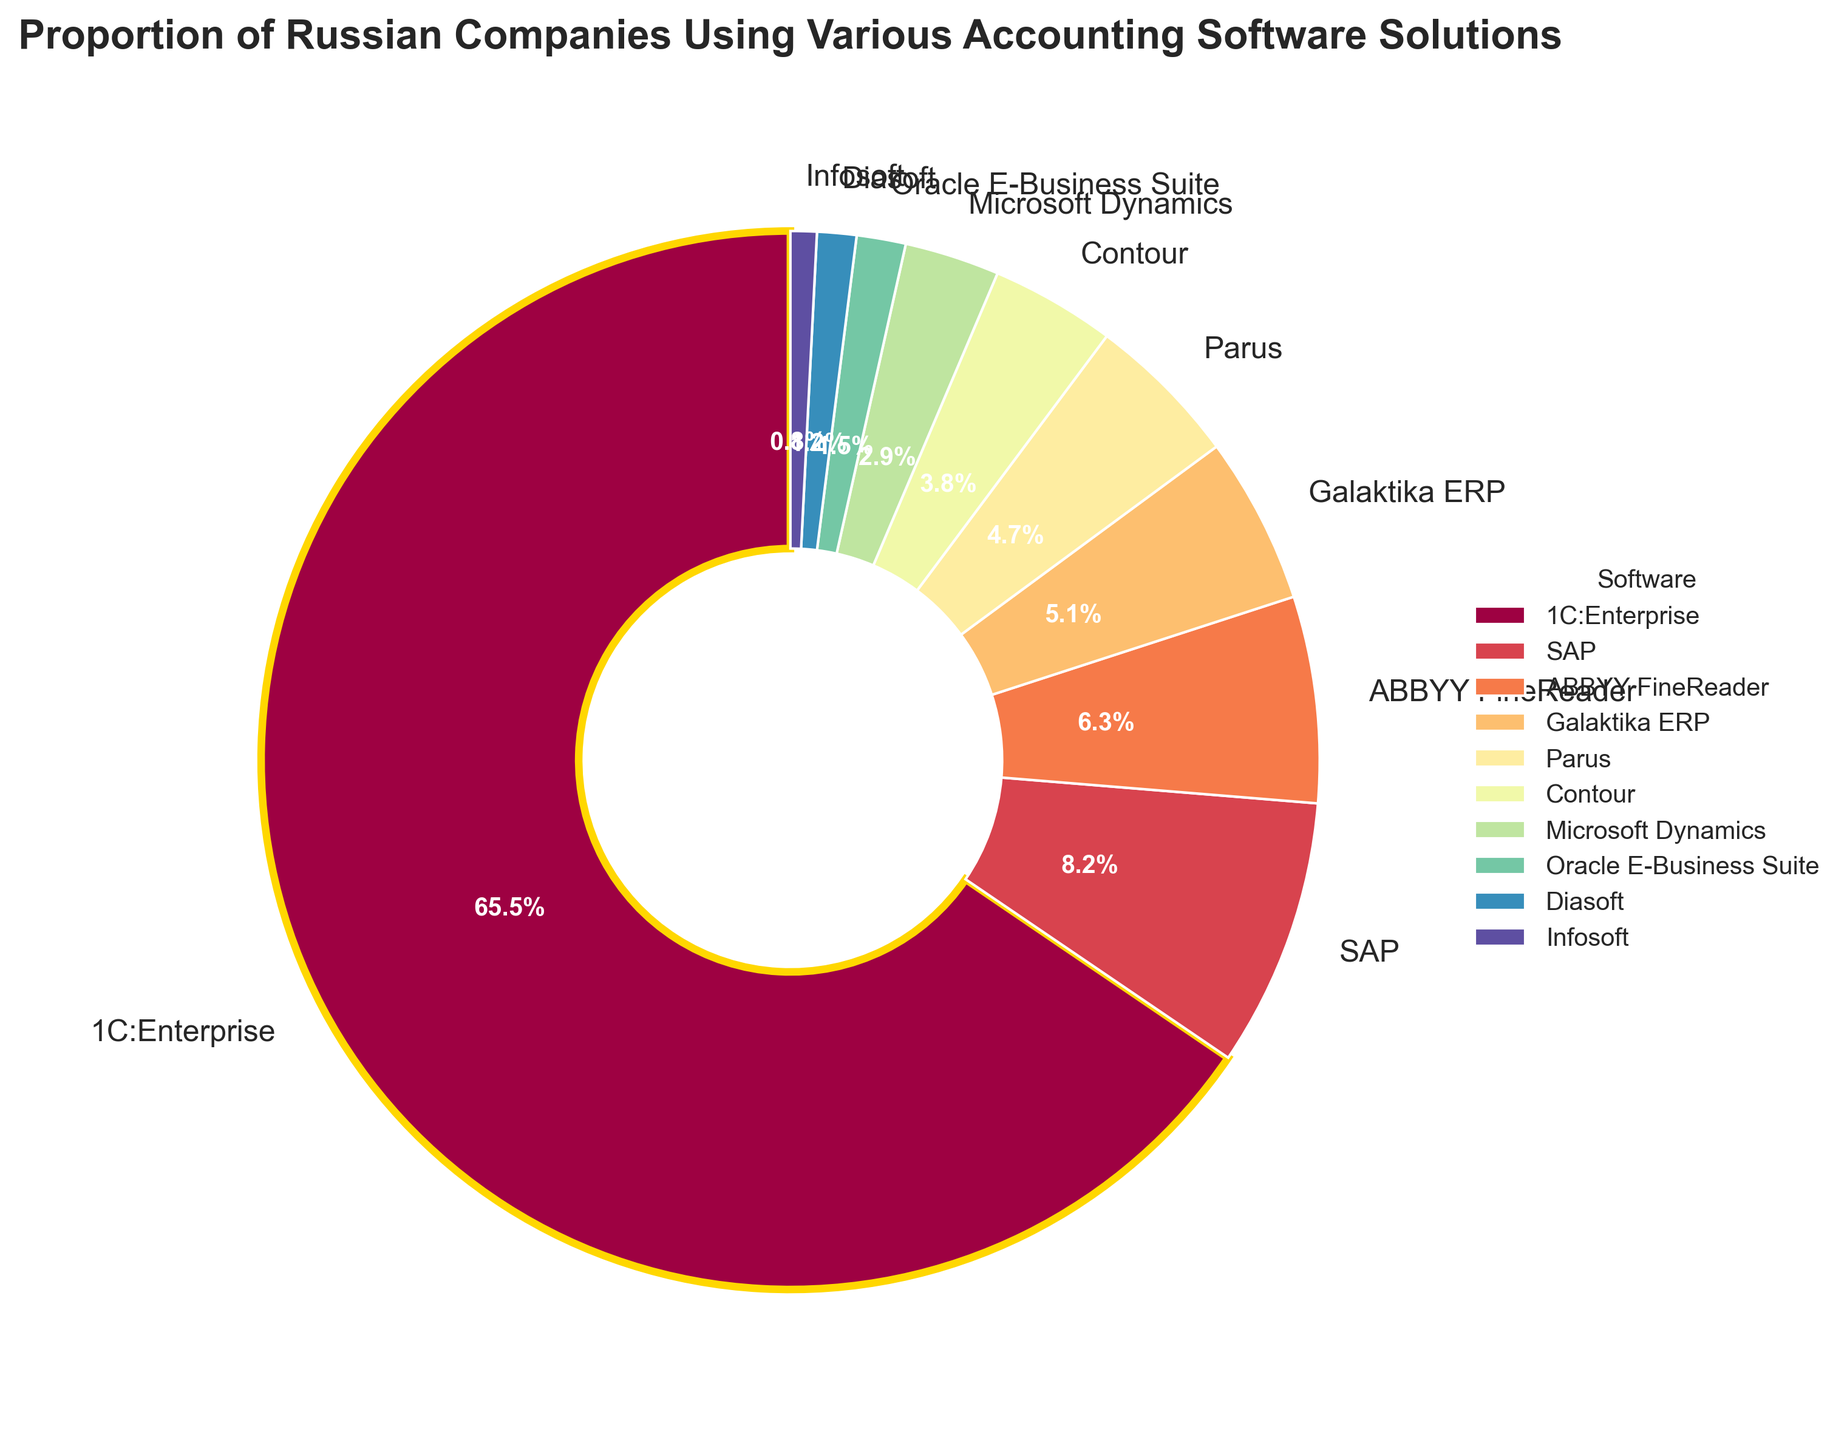What is the most used accounting software among Russian companies? The software with the largest slice in the pie chart is "1C:Enterprise." This is indicated by its prominent wedge and the 65.5% label, showing it is the most used accounting software.
Answer: 1C:Enterprise Which accounting software has the second-highest usage after 1C:Enterprise? Looking at the pie chart, the segment next in size after 1C:Enterprise is SAP, which has an 8.2% usage rate. This makes it the second most used software.
Answer: SAP How much more popular is 1C:Enterprise compared to Microsoft Dynamics? By comparing the percentages, 1C:Enterprise has 65.5% while Microsoft Dynamics has 2.9%. The difference in popularity is 65.5% - 2.9% = 62.6%.
Answer: 62.6% What is the total percentage of companies using SAP, ABBYY FineReader, and Galaktika ERP combined? Adding the individual percentages: SAP (8.2%) + ABBYY FineReader (6.3%) + Galaktika ERP (5.1%) = 19.6%.
Answer: 19.6% Are there accounting software solutions that have less than 2% usage? If so, which ones? The pie chart shows Oracle E-Business Suite at 1.5%, Diasoft at 1.2%, and Infosoft at 0.8%, all under 2% usage.
Answer: Oracle E-Business Suite, Diasoft, Infosoft How does the usage of Oracle E-Business Suite compare to that of Infosoft? Oracle E-Business Suite is used by 1.5% of companies, while Infosoft is used by 0.8%. Oracle E-Business Suite is used by a higher percentage, specifically 0.7% more.
Answer: Oracle E-Business Suite is more used by 0.7% Which accounting software solutions are used by more companies than Microsoft Dynamics? The pie chart indicates software solutions with higher usage percentages than Microsoft Dynamics (2.9%): 1C:Enterprise (65.5%), SAP (8.2%), ABBYY FineReader (6.3%), Galaktika ERP (5.1%), and Parus (4.7%).
Answer: 1C:Enterprise, SAP, ABBYY FineReader, Galaktika ERP, Parus How many accounting software solutions have more than 5% usage? By checking the percentage for each software, there are three solutions with more than 5% usage: 1C:Enterprise (65.5%), SAP (8.2%), and ABBYY FineReader (6.3%).
Answer: 3 Which accounting software solution is highlighted by a special edge color in the pie chart, and what is the color of the special edge? The software "1C:Enterprise" is highlighted with a gold edge in the pie chart, indicating its importance.
Answer: 1C:Enterprise with a gold edge 